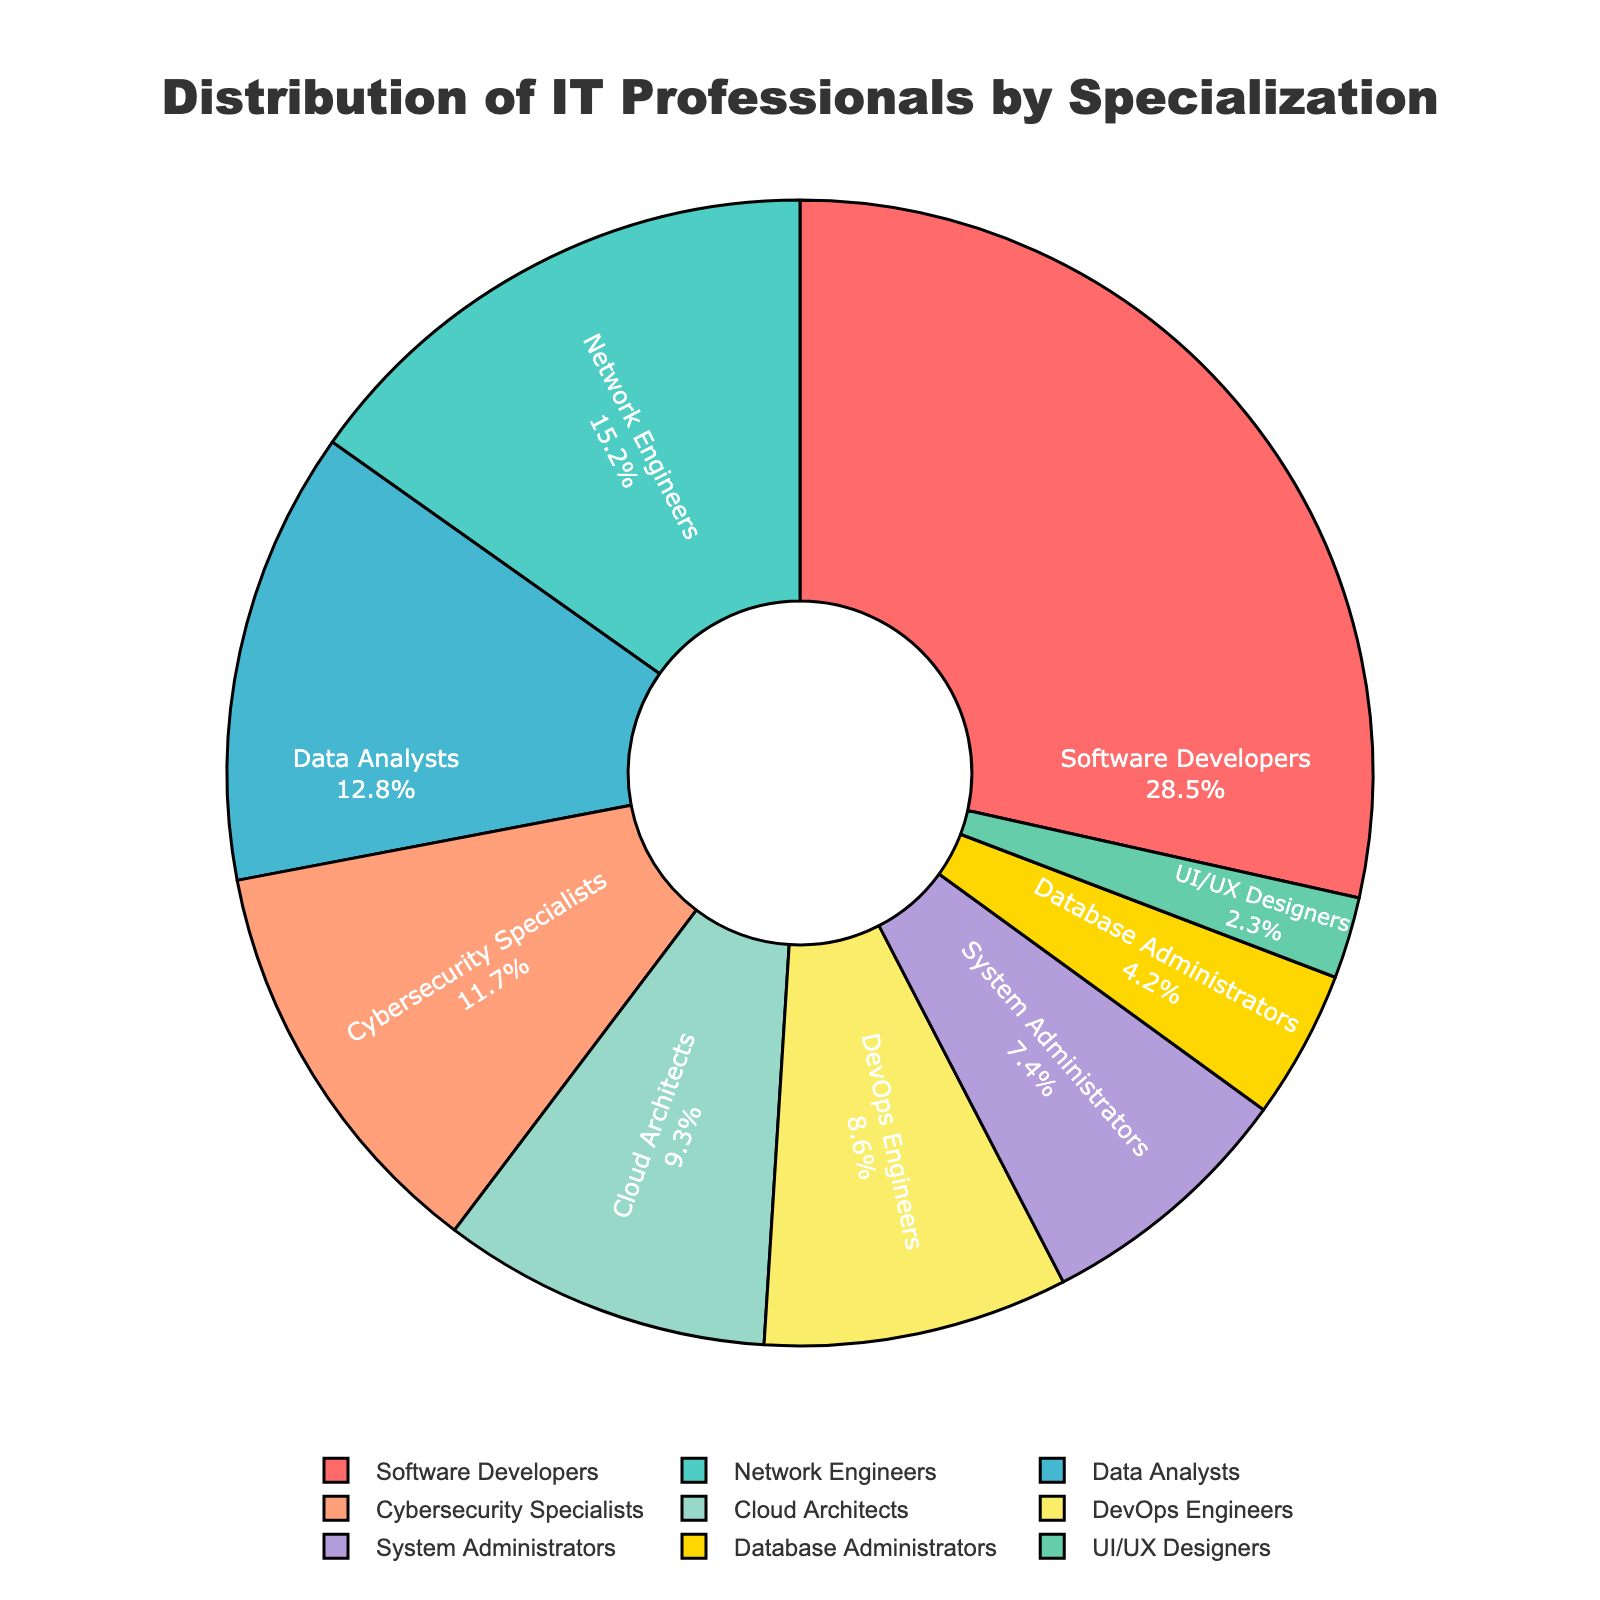What is the most common IT specialization shown in the pie chart? The specialization with the largest slice in the pie chart is the one that has the highest percentage. In this case, "Software Developers" has the largest percentage of 28.5%.
Answer: Software Developers Which two specializations together make up more than one-third of the IT professionals? Adding the percentages of the top two specializations, "Software Developers" (28.5%) and "Network Engineers" (15.2%), we get 28.5% + 15.2% = 43.7%, which is more than one-third (33.3%).
Answer: Software Developers and Network Engineers How much greater is the percentage of Software Developers compared to UI/UX Designers? The percentage of Software Developers is 28.5% and UI/UX Designers is 2.3%. The difference is 28.5% - 2.3% = 26.2%.
Answer: 26.2% What is the total percentage for the specializations with less than 10% representation? Summing the percentages of Cloud Architects (9.3%), DevOps Engineers (8.6%), System Administrators (7.4%), Database Administrators (4.2%), and UI/UX Designers (2.3%) gives 9.3% + 8.6% + 7.4% + 4.2% + 2.3% = 31.8%.
Answer: 31.8% How does the representation of Cybersecurity Specialists compare to that of Cloud Architects visually in the pie chart? Cybersecurity Specialists have a slightly larger slice compared to Cloud Architects. Cybersecurity Specialists have 11.7% while Cloud Architects have 9.3%, which can be seen in the smaller area of the chart occupied by Cloud Architects.
Answer: Cybersecurity Specialists have a larger slice Which specialization is represented by the green slice? By inspecting the pie chart colors, the green slice corresponds to "Network Engineers".
Answer: Network Engineers How many specializations have a percentage greater than the average percentage of all the specializations? There are 9 specializations. The average percentage is (28.5% + 15.2% + 12.8% + 11.7% + 9.3% + 8.6% + 7.4% + 4.2% + 2.3%) / 9 = 11.1%. The specializations greater than this average are "Software Developers" (28.5%), "Network Engineers" (15.2%), "Data Analysts" (12.8%), and "Cybersecurity Specialists" (11.7%), which are 4 in total.
Answer: 4 